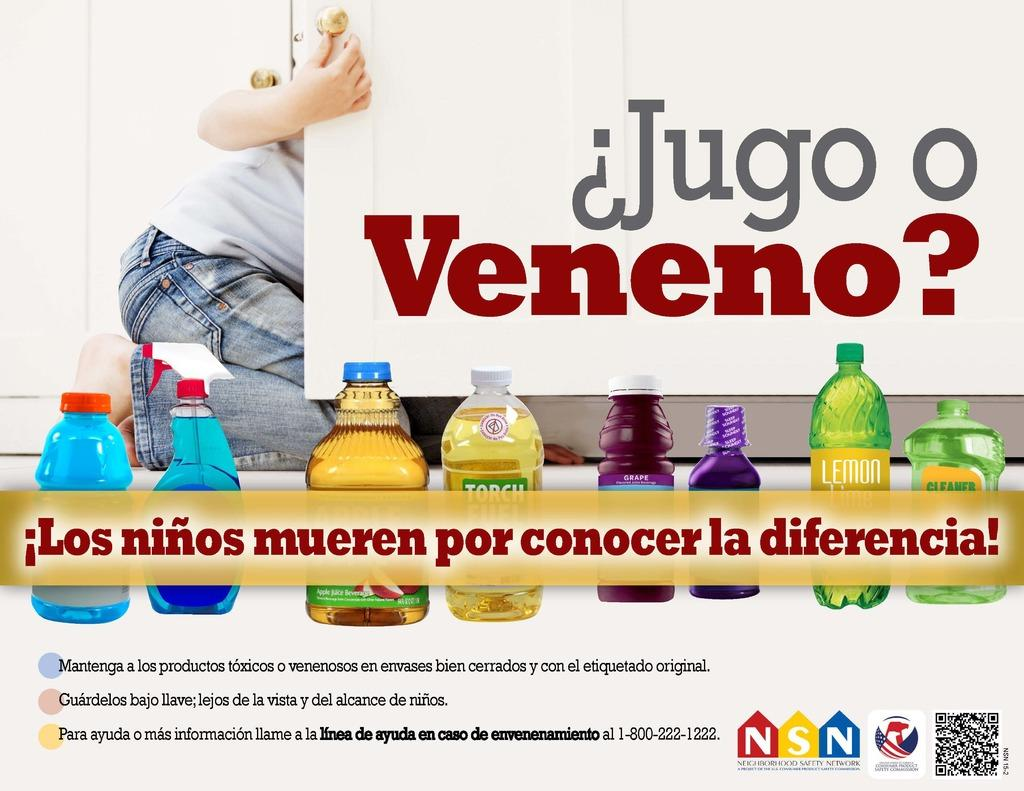<image>
Present a compact description of the photo's key features. A sign with a kid on it made by the Neighborhood Safety Network. 